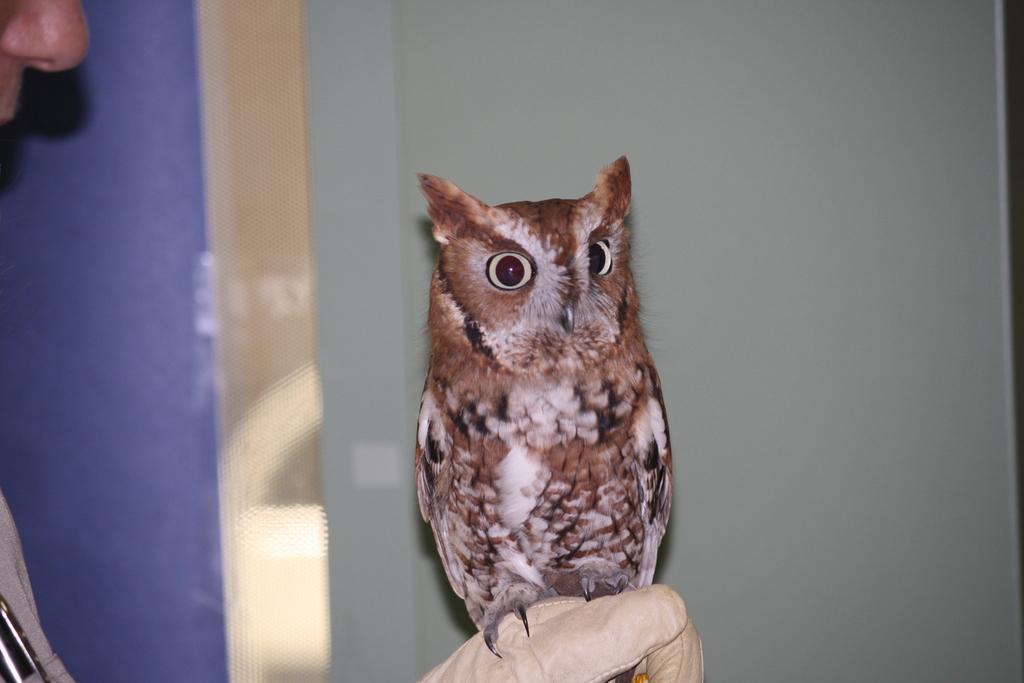Describe this image in one or two sentences. In this picture there is a brown color owl sitting on the man hand. Behind there is a grey color wall. 